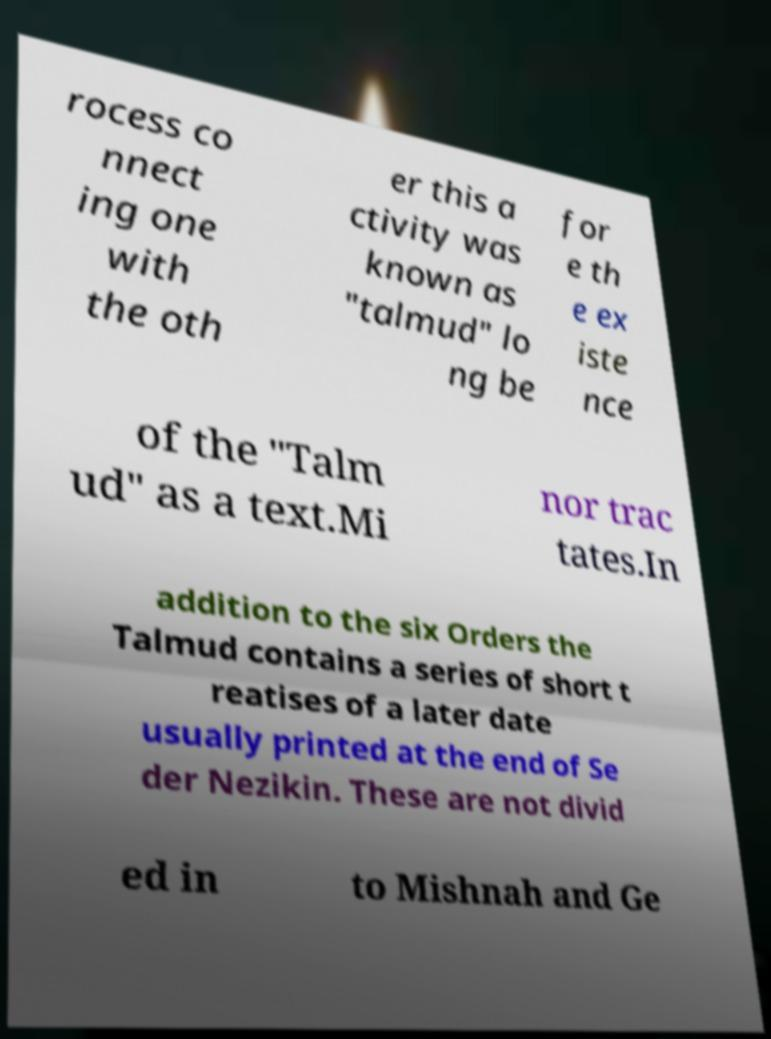There's text embedded in this image that I need extracted. Can you transcribe it verbatim? rocess co nnect ing one with the oth er this a ctivity was known as "talmud" lo ng be for e th e ex iste nce of the "Talm ud" as a text.Mi nor trac tates.In addition to the six Orders the Talmud contains a series of short t reatises of a later date usually printed at the end of Se der Nezikin. These are not divid ed in to Mishnah and Ge 